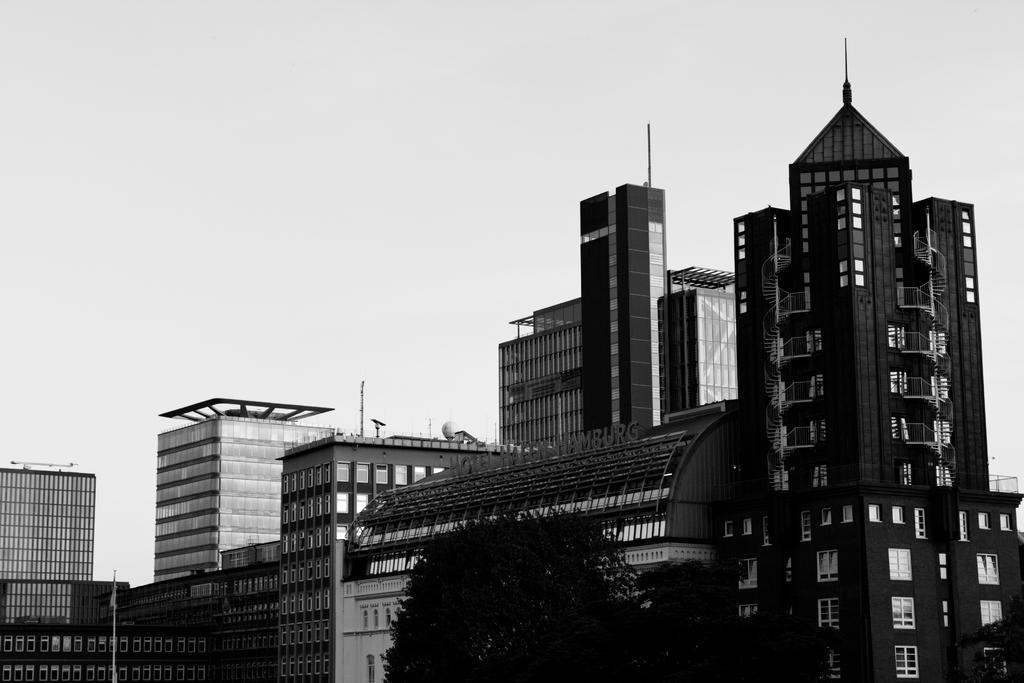Could you give a brief overview of what you see in this image? In this image I can see few trees and buildings and I can also see the sky and the image is in black and white. 